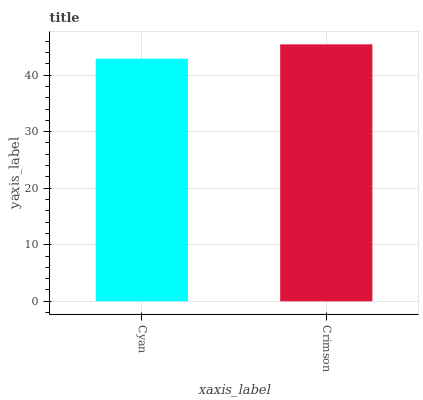Is Cyan the minimum?
Answer yes or no. Yes. Is Crimson the maximum?
Answer yes or no. Yes. Is Crimson the minimum?
Answer yes or no. No. Is Crimson greater than Cyan?
Answer yes or no. Yes. Is Cyan less than Crimson?
Answer yes or no. Yes. Is Cyan greater than Crimson?
Answer yes or no. No. Is Crimson less than Cyan?
Answer yes or no. No. Is Crimson the high median?
Answer yes or no. Yes. Is Cyan the low median?
Answer yes or no. Yes. Is Cyan the high median?
Answer yes or no. No. Is Crimson the low median?
Answer yes or no. No. 